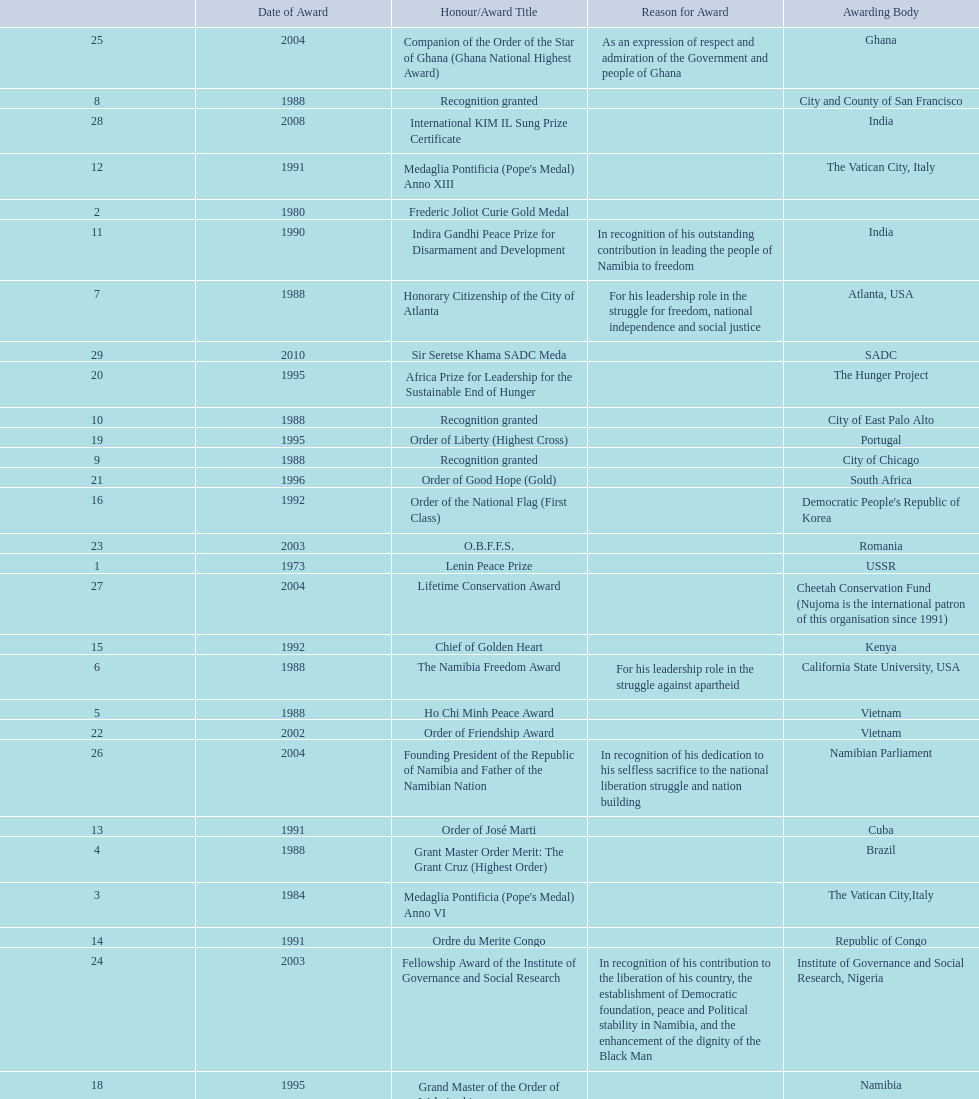What is the last honors/award title listed on this chart? Sir Seretse Khama SADC Meda. 